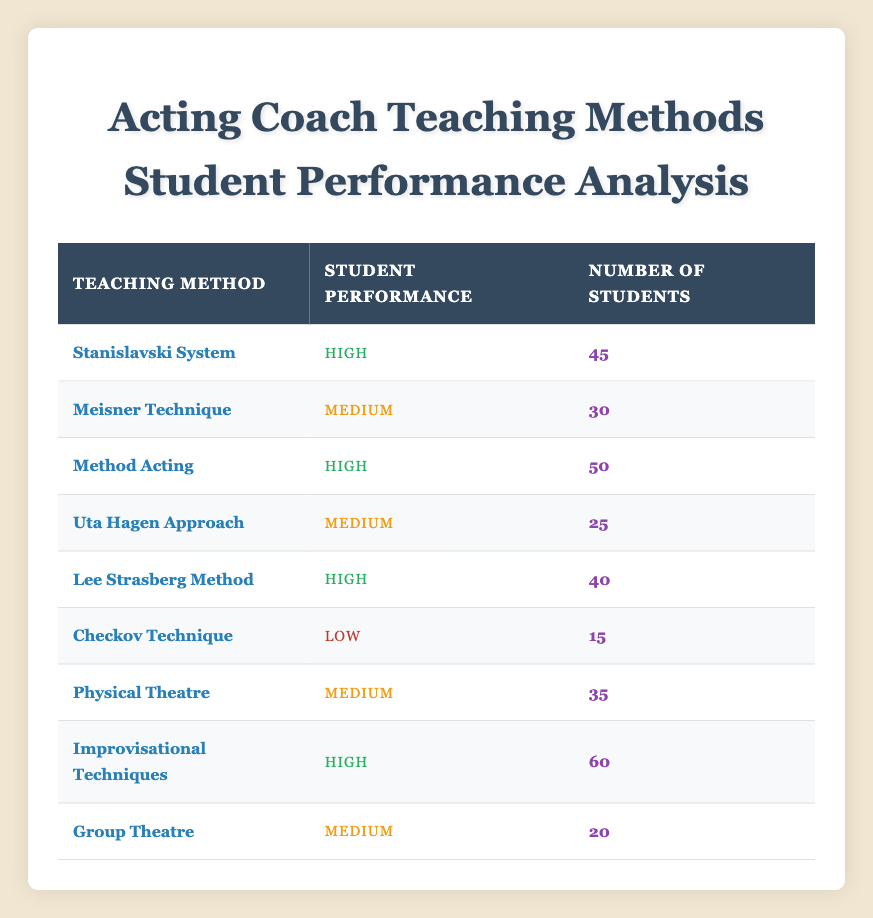What is the total number of students taught using the Meisner Technique? The table shows that the Meisner Technique has 30 students. Therefore, the total number of students taught using this method is simply the value given in the table.
Answer: 30 Which teaching method has the highest student performance rating? By scanning the Student Performance column, we can see that "High" is the top rating. The teaching methods with this rating include Stanislavski System, Method Acting, Lee Strasberg Method, and Improvisational Techniques.
Answer: Stanislavski System, Method Acting, Lee Strasberg Method, Improvisational Techniques How many students were taught using a teaching method that resulted in low performance? The only method with a low student performance rating is the Checkov Technique, which has 15 students. So, the total number of students in this category is taken directly from the table.
Answer: 15 What is the average number of students across all teaching methods? To find the average, we first sum the number of students from all methods: 45 + 30 + 50 + 25 + 40 + 15 + 35 + 60 + 20 = 350. There are 9 different teaching methods, so the average is 350 divided by 9, which is approximately 38.89.
Answer: 38.89 Is there any teaching method with medium performance that has more students than the Checkov Technique? The Checkov Technique has 15 students. Comparing it to the medium performance methods (Meisner Technique, Uta Hagen Approach, Physical Theatre, Group Theatre), we see Meisner Technique (30), Uta Hagen Approach (25), and Physical Theatre (35) all have more students.
Answer: Yes How many more students were taught using the Improvisational Techniques compared to the Uta Hagen Approach? The Improvisational Techniques have 60 students, while the Uta Hagen Approach has 25 students. To find the difference, we subtract 25 from 60, resulting in 35 more students.
Answer: 35 Which teaching method had the lowest number of students? By examining the Number of Students column, we see that the Checkov Technique has the lowest count with 15 students, making it the method with the least student engagement.
Answer: Checkov Technique What percentage of the total students received high performance ratings? To find this, we first count the total number of students with high performance: 45 (Stanislavski System) + 50 (Method Acting) + 40 (Lee Strasberg Method) + 60 (Improvisational Techniques) = 195. The total number of students is 350. The percentage is then calculated as (195/350) * 100, which is approximately 55.71%.
Answer: 55.71% 